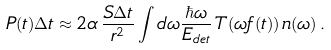Convert formula to latex. <formula><loc_0><loc_0><loc_500><loc_500>P ( t ) \Delta t \approx 2 \alpha \, \frac { S \Delta t } { r ^ { 2 } } \int d \omega \frac { \hbar { \omega } } { E _ { d e t } } \, T ( \omega f ( t ) ) \, n ( \omega ) \, .</formula> 